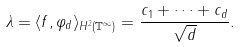Convert formula to latex. <formula><loc_0><loc_0><loc_500><loc_500>\lambda = \langle f , \varphi _ { d } \rangle _ { H ^ { 2 } ( \mathbb { T } ^ { \infty } ) } = \frac { c _ { 1 } + \cdots + c _ { d } } { \sqrt { d } } .</formula> 